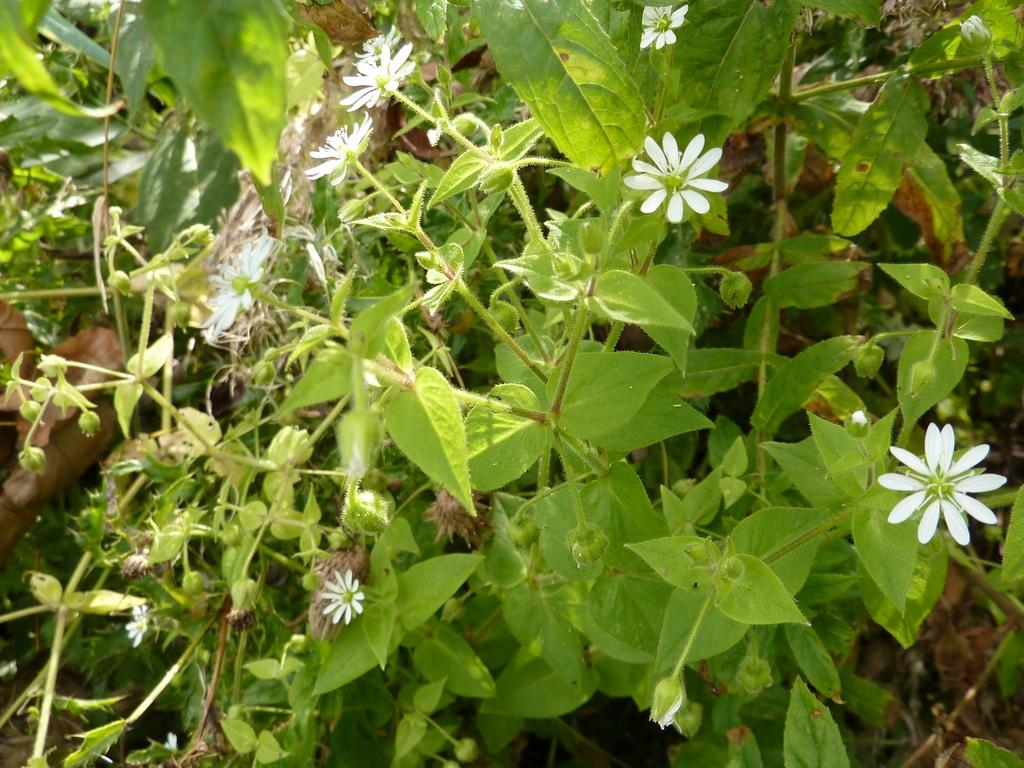What type of plants are visible in the image? There are flowers and leaves visible in the image. Where are the flowers and leaves located on the plants? The flowers and leaves are on the stems of the plants. What type of basin can be seen in the image? There is no basin present in the image; it features flowers and leaves on plant stems. How many boys are visible in the image? There are no boys present in the image. 